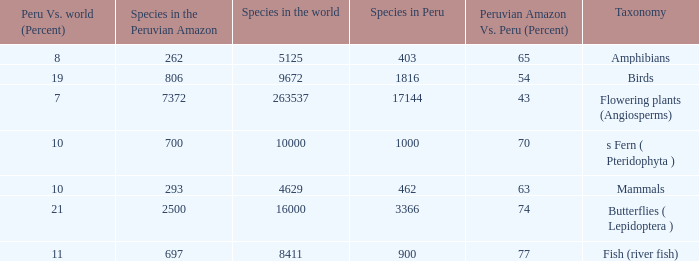What's the maximum peru vs. world (percent) with 9672 species in the world  19.0. 